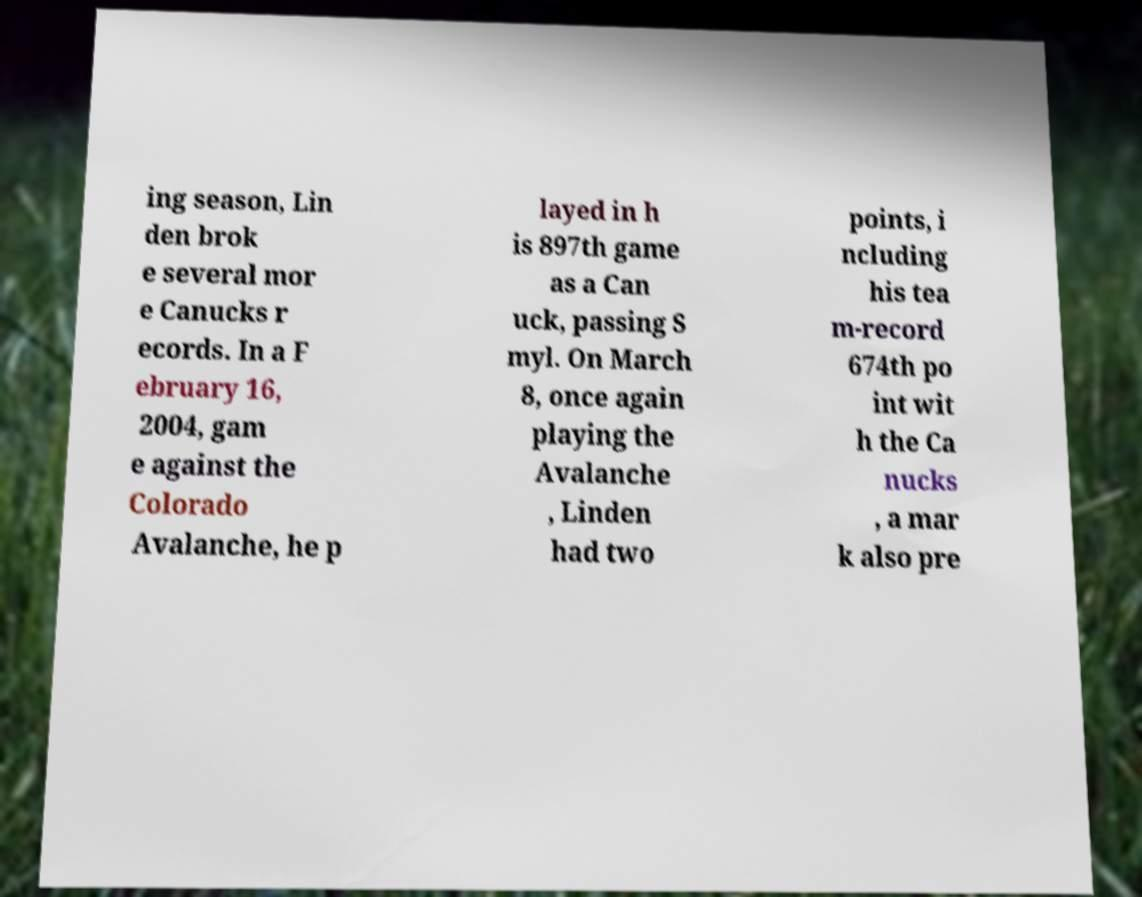I need the written content from this picture converted into text. Can you do that? ing season, Lin den brok e several mor e Canucks r ecords. In a F ebruary 16, 2004, gam e against the Colorado Avalanche, he p layed in h is 897th game as a Can uck, passing S myl. On March 8, once again playing the Avalanche , Linden had two points, i ncluding his tea m-record 674th po int wit h the Ca nucks , a mar k also pre 